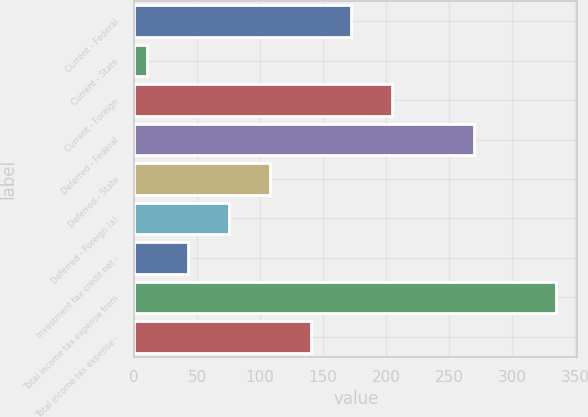Convert chart to OTSL. <chart><loc_0><loc_0><loc_500><loc_500><bar_chart><fcel>Current - Federal<fcel>Current - State<fcel>Current - Foreign<fcel>Deferred - Federal<fcel>Deferred - State<fcel>Deferred - Foreign (a)<fcel>Investment tax credit net -<fcel>Total income tax expense from<fcel>Total income tax expense -<nl><fcel>172.5<fcel>10<fcel>205<fcel>270<fcel>107.5<fcel>75<fcel>42.5<fcel>335<fcel>140<nl></chart> 